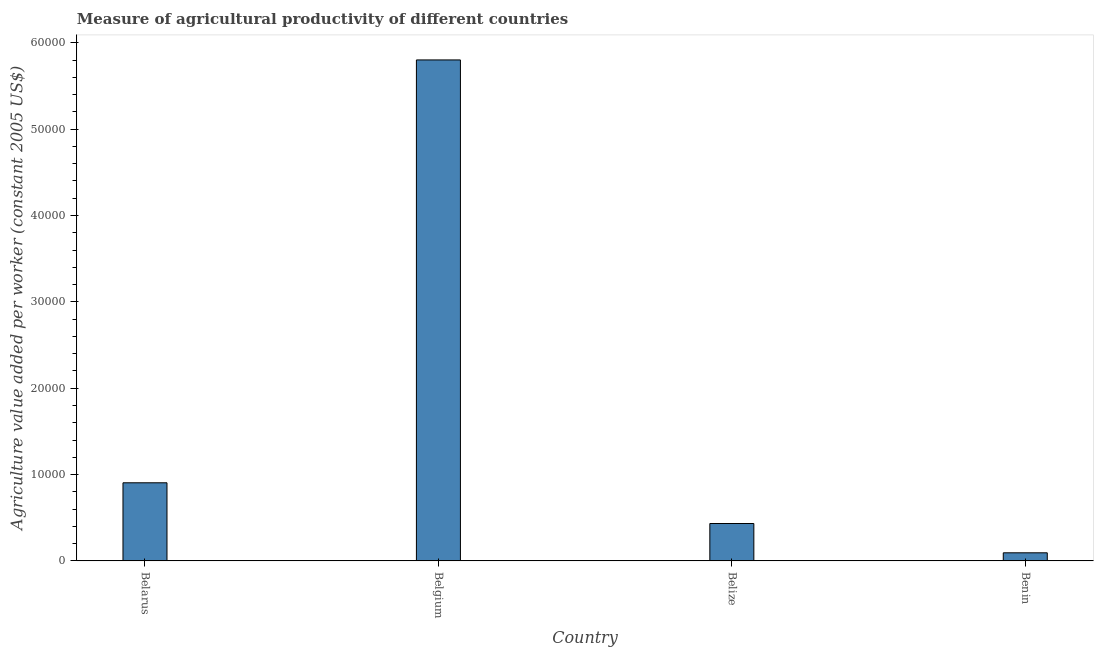Does the graph contain any zero values?
Offer a terse response. No. Does the graph contain grids?
Provide a short and direct response. No. What is the title of the graph?
Ensure brevity in your answer.  Measure of agricultural productivity of different countries. What is the label or title of the X-axis?
Your answer should be compact. Country. What is the label or title of the Y-axis?
Offer a very short reply. Agriculture value added per worker (constant 2005 US$). What is the agriculture value added per worker in Belarus?
Provide a succinct answer. 9046.43. Across all countries, what is the maximum agriculture value added per worker?
Offer a very short reply. 5.80e+04. Across all countries, what is the minimum agriculture value added per worker?
Your answer should be compact. 936.84. In which country was the agriculture value added per worker maximum?
Make the answer very short. Belgium. In which country was the agriculture value added per worker minimum?
Offer a terse response. Benin. What is the sum of the agriculture value added per worker?
Your response must be concise. 7.23e+04. What is the difference between the agriculture value added per worker in Belgium and Belize?
Give a very brief answer. 5.37e+04. What is the average agriculture value added per worker per country?
Your answer should be very brief. 1.81e+04. What is the median agriculture value added per worker?
Offer a very short reply. 6688.8. What is the ratio of the agriculture value added per worker in Belgium to that in Benin?
Keep it short and to the point. 61.93. Is the agriculture value added per worker in Belarus less than that in Benin?
Offer a terse response. No. Is the difference between the agriculture value added per worker in Belarus and Benin greater than the difference between any two countries?
Give a very brief answer. No. What is the difference between the highest and the second highest agriculture value added per worker?
Keep it short and to the point. 4.90e+04. Is the sum of the agriculture value added per worker in Belarus and Belgium greater than the maximum agriculture value added per worker across all countries?
Your response must be concise. Yes. What is the difference between the highest and the lowest agriculture value added per worker?
Keep it short and to the point. 5.71e+04. Are all the bars in the graph horizontal?
Offer a terse response. No. What is the Agriculture value added per worker (constant 2005 US$) in Belarus?
Keep it short and to the point. 9046.43. What is the Agriculture value added per worker (constant 2005 US$) of Belgium?
Make the answer very short. 5.80e+04. What is the Agriculture value added per worker (constant 2005 US$) in Belize?
Keep it short and to the point. 4331.18. What is the Agriculture value added per worker (constant 2005 US$) in Benin?
Your response must be concise. 936.84. What is the difference between the Agriculture value added per worker (constant 2005 US$) in Belarus and Belgium?
Provide a short and direct response. -4.90e+04. What is the difference between the Agriculture value added per worker (constant 2005 US$) in Belarus and Belize?
Ensure brevity in your answer.  4715.25. What is the difference between the Agriculture value added per worker (constant 2005 US$) in Belarus and Benin?
Provide a short and direct response. 8109.58. What is the difference between the Agriculture value added per worker (constant 2005 US$) in Belgium and Belize?
Offer a terse response. 5.37e+04. What is the difference between the Agriculture value added per worker (constant 2005 US$) in Belgium and Benin?
Ensure brevity in your answer.  5.71e+04. What is the difference between the Agriculture value added per worker (constant 2005 US$) in Belize and Benin?
Give a very brief answer. 3394.33. What is the ratio of the Agriculture value added per worker (constant 2005 US$) in Belarus to that in Belgium?
Make the answer very short. 0.16. What is the ratio of the Agriculture value added per worker (constant 2005 US$) in Belarus to that in Belize?
Give a very brief answer. 2.09. What is the ratio of the Agriculture value added per worker (constant 2005 US$) in Belarus to that in Benin?
Give a very brief answer. 9.66. What is the ratio of the Agriculture value added per worker (constant 2005 US$) in Belgium to that in Belize?
Keep it short and to the point. 13.4. What is the ratio of the Agriculture value added per worker (constant 2005 US$) in Belgium to that in Benin?
Your response must be concise. 61.93. What is the ratio of the Agriculture value added per worker (constant 2005 US$) in Belize to that in Benin?
Provide a short and direct response. 4.62. 